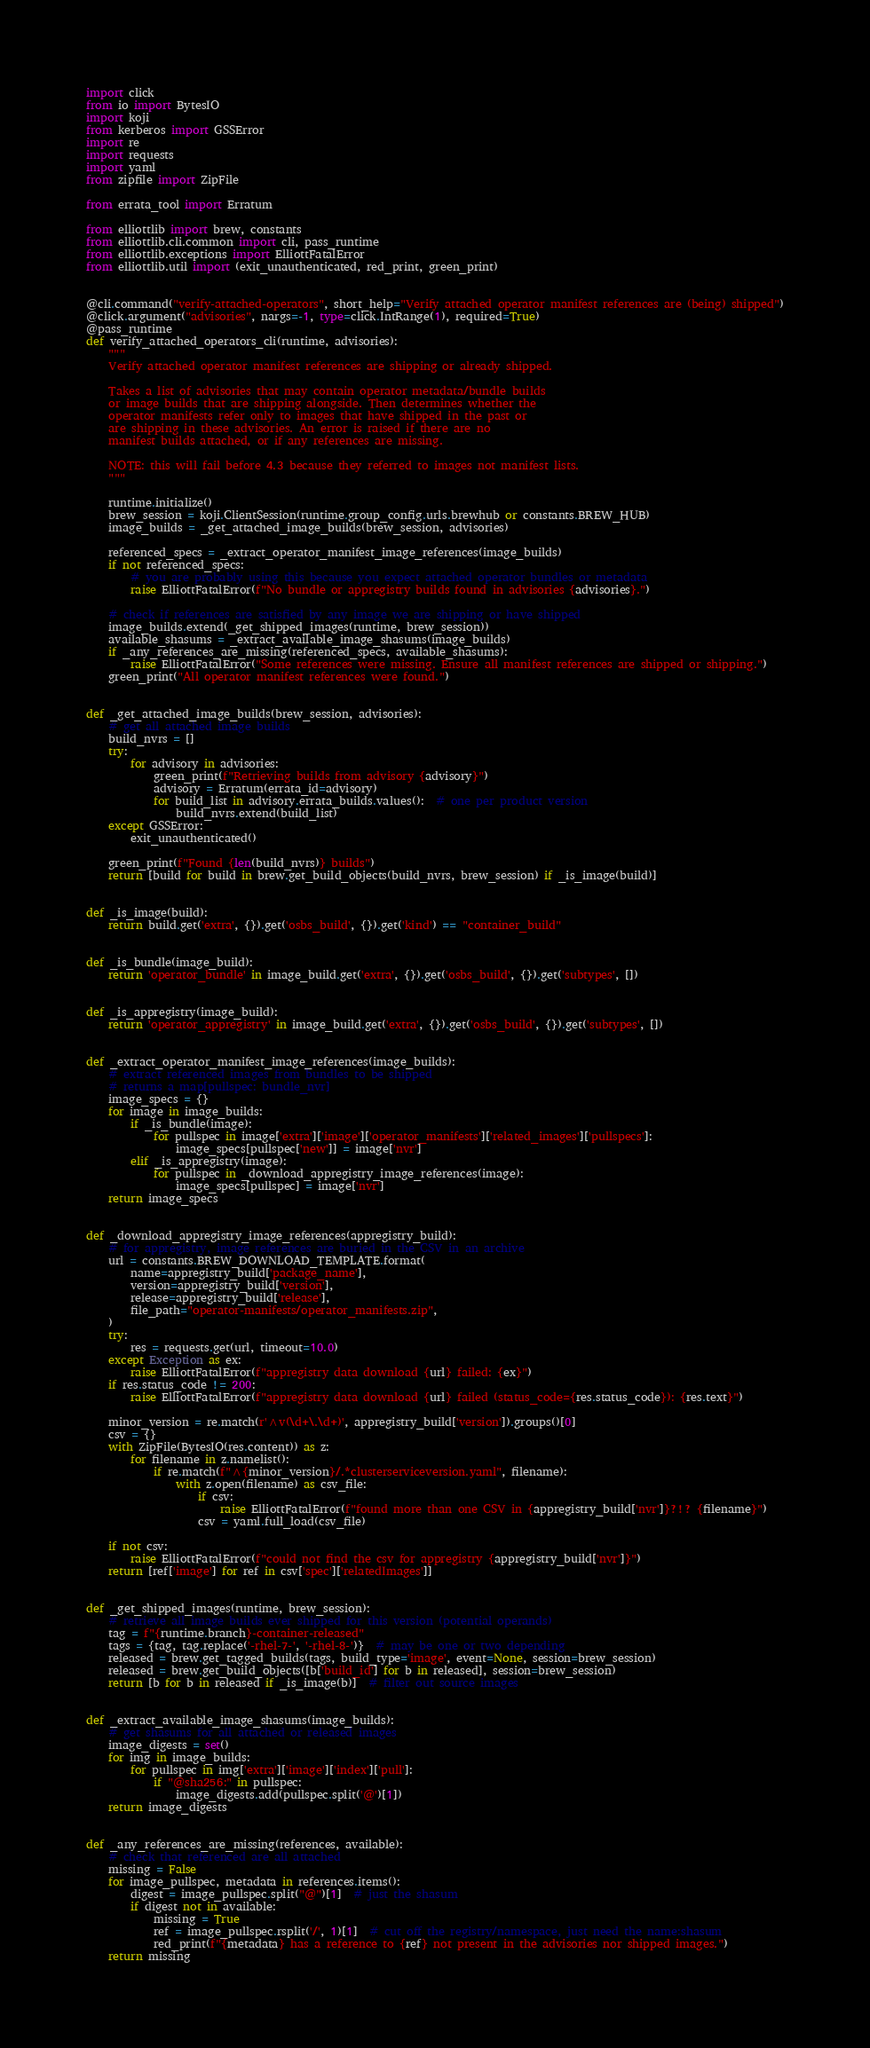Convert code to text. <code><loc_0><loc_0><loc_500><loc_500><_Python_>import click
from io import BytesIO
import koji
from kerberos import GSSError
import re
import requests
import yaml
from zipfile import ZipFile

from errata_tool import Erratum

from elliottlib import brew, constants
from elliottlib.cli.common import cli, pass_runtime
from elliottlib.exceptions import ElliottFatalError
from elliottlib.util import (exit_unauthenticated, red_print, green_print)


@cli.command("verify-attached-operators", short_help="Verify attached operator manifest references are (being) shipped")
@click.argument("advisories", nargs=-1, type=click.IntRange(1), required=True)
@pass_runtime
def verify_attached_operators_cli(runtime, advisories):
    """
    Verify attached operator manifest references are shipping or already shipped.

    Takes a list of advisories that may contain operator metadata/bundle builds
    or image builds that are shipping alongside. Then determines whether the
    operator manifests refer only to images that have shipped in the past or
    are shipping in these advisories. An error is raised if there are no
    manifest builds attached, or if any references are missing.

    NOTE: this will fail before 4.3 because they referred to images not manifest lists.
    """

    runtime.initialize()
    brew_session = koji.ClientSession(runtime.group_config.urls.brewhub or constants.BREW_HUB)
    image_builds = _get_attached_image_builds(brew_session, advisories)

    referenced_specs = _extract_operator_manifest_image_references(image_builds)
    if not referenced_specs:
        # you are probably using this because you expect attached operator bundles or metadata
        raise ElliottFatalError(f"No bundle or appregistry builds found in advisories {advisories}.")

    # check if references are satisfied by any image we are shipping or have shipped
    image_builds.extend(_get_shipped_images(runtime, brew_session))
    available_shasums = _extract_available_image_shasums(image_builds)
    if _any_references_are_missing(referenced_specs, available_shasums):
        raise ElliottFatalError("Some references were missing. Ensure all manifest references are shipped or shipping.")
    green_print("All operator manifest references were found.")


def _get_attached_image_builds(brew_session, advisories):
    # get all attached image builds
    build_nvrs = []
    try:
        for advisory in advisories:
            green_print(f"Retrieving builds from advisory {advisory}")
            advisory = Erratum(errata_id=advisory)
            for build_list in advisory.errata_builds.values():  # one per product version
                build_nvrs.extend(build_list)
    except GSSError:
        exit_unauthenticated()

    green_print(f"Found {len(build_nvrs)} builds")
    return [build for build in brew.get_build_objects(build_nvrs, brew_session) if _is_image(build)]


def _is_image(build):
    return build.get('extra', {}).get('osbs_build', {}).get('kind') == "container_build"


def _is_bundle(image_build):
    return 'operator_bundle' in image_build.get('extra', {}).get('osbs_build', {}).get('subtypes', [])


def _is_appregistry(image_build):
    return 'operator_appregistry' in image_build.get('extra', {}).get('osbs_build', {}).get('subtypes', [])


def _extract_operator_manifest_image_references(image_builds):
    # extract referenced images from bundles to be shipped
    # returns a map[pullspec: bundle_nvr]
    image_specs = {}
    for image in image_builds:
        if _is_bundle(image):
            for pullspec in image['extra']['image']['operator_manifests']['related_images']['pullspecs']:
                image_specs[pullspec['new']] = image['nvr']
        elif _is_appregistry(image):
            for pullspec in _download_appregistry_image_references(image):
                image_specs[pullspec] = image['nvr']
    return image_specs


def _download_appregistry_image_references(appregistry_build):
    # for appregistry, image references are buried in the CSV in an archive
    url = constants.BREW_DOWNLOAD_TEMPLATE.format(
        name=appregistry_build['package_name'],
        version=appregistry_build['version'],
        release=appregistry_build['release'],
        file_path="operator-manifests/operator_manifests.zip",
    )
    try:
        res = requests.get(url, timeout=10.0)
    except Exception as ex:
        raise ElliottFatalError(f"appregistry data download {url} failed: {ex}")
    if res.status_code != 200:
        raise ElliottFatalError(f"appregistry data download {url} failed (status_code={res.status_code}): {res.text}")

    minor_version = re.match(r'^v(\d+\.\d+)', appregistry_build['version']).groups()[0]
    csv = {}
    with ZipFile(BytesIO(res.content)) as z:
        for filename in z.namelist():
            if re.match(f"^{minor_version}/.*clusterserviceversion.yaml", filename):
                with z.open(filename) as csv_file:
                    if csv:
                        raise ElliottFatalError(f"found more than one CSV in {appregistry_build['nvr']}?!? {filename}")
                    csv = yaml.full_load(csv_file)

    if not csv:
        raise ElliottFatalError(f"could not find the csv for appregistry {appregistry_build['nvr']}")
    return [ref['image'] for ref in csv['spec']['relatedImages']]


def _get_shipped_images(runtime, brew_session):
    # retrieve all image builds ever shipped for this version (potential operands)
    tag = f"{runtime.branch}-container-released"
    tags = {tag, tag.replace('-rhel-7-', '-rhel-8-')}  # may be one or two depending
    released = brew.get_tagged_builds(tags, build_type='image', event=None, session=brew_session)
    released = brew.get_build_objects([b['build_id'] for b in released], session=brew_session)
    return [b for b in released if _is_image(b)]  # filter out source images


def _extract_available_image_shasums(image_builds):
    # get shasums for all attached or released images
    image_digests = set()
    for img in image_builds:
        for pullspec in img['extra']['image']['index']['pull']:
            if "@sha256:" in pullspec:
                image_digests.add(pullspec.split('@')[1])
    return image_digests


def _any_references_are_missing(references, available):
    # check that referenced are all attached
    missing = False
    for image_pullspec, metadata in references.items():
        digest = image_pullspec.split("@")[1]  # just the shasum
        if digest not in available:
            missing = True
            ref = image_pullspec.rsplit('/', 1)[1]  # cut off the registry/namespace, just need the name:shasum
            red_print(f"{metadata} has a reference to {ref} not present in the advisories nor shipped images.")
    return missing
</code> 